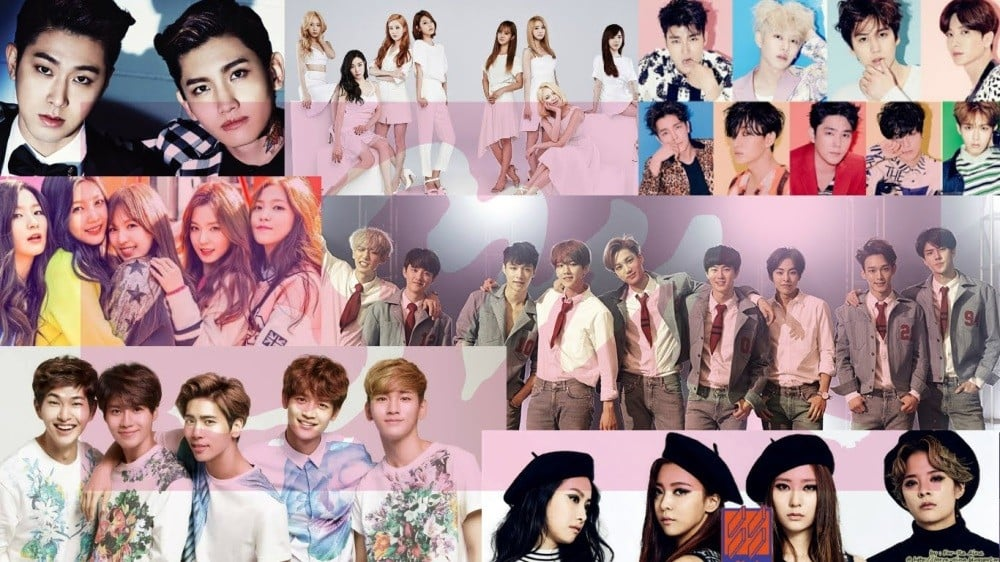Can you describe a short scenario where the members of these groups collaborate on a significant cultural event, showcasing their styles? In a grand cultural festival celebrating unity and diversity, members from these K-pop groups come together to curate a breathtaking performance. Each group brings their distinct fashion styles, creating a vibrant mosaic of colors, textures, and trends. The stage is a massive, futuristic platform designed to reflect the overarching theme of harmony and progress. As the performance begins, the members intermingle, their coordinated outfits glowing under the dynamic lighting. The choreography seamlessly blends the unique styles of each group, highlighting their individuality while celebrating their unity. The event culminates in a spectacular finale where all members, dressed in an elegant fusion of all their styles, create a living representation of cultural confluence. The audience is left mesmerized, witnessing a powerful visual and artistic statement that transcends the boundaries of fashion and music. 
How might the individual styles of the K-pop groups reflect their different musical genres within the industry? The individual styles of the K-pop groups reflect their diverse musical genres within the industry, with each group's fashion meticulously tailored to complement their sound and thematic elements. A group with a bold, edgy look featuring leather jackets and dark colors likely aligns with a powerful, high-energy genre like rock or hip-hop, encapsulating the rebellious spirit and intensity of their music. In contrast, a group sporting pastel hues, floral prints, and casual outfits might embody a softer, more melodic pop genre, their visually light and airy style resonating with the upbeat, catchy tunes they produce. Another group wearing avant-garde fashion with experimental cuts and bold patterns could represent an innovative, genre-blending style, pushing the boundaries of music just as they do with their fashion. Lastly, a group with a timeless, sophisticated aesthetic, including tailored suits and classic attire, might convey a genre rooted in R&B or soul, reflecting the depth and elegance of their musical narrative. Through their distinct styles, these K-pop groups not only enhance their stage presence but also provide a visual cue to audiences about the essence and genre of their music. 